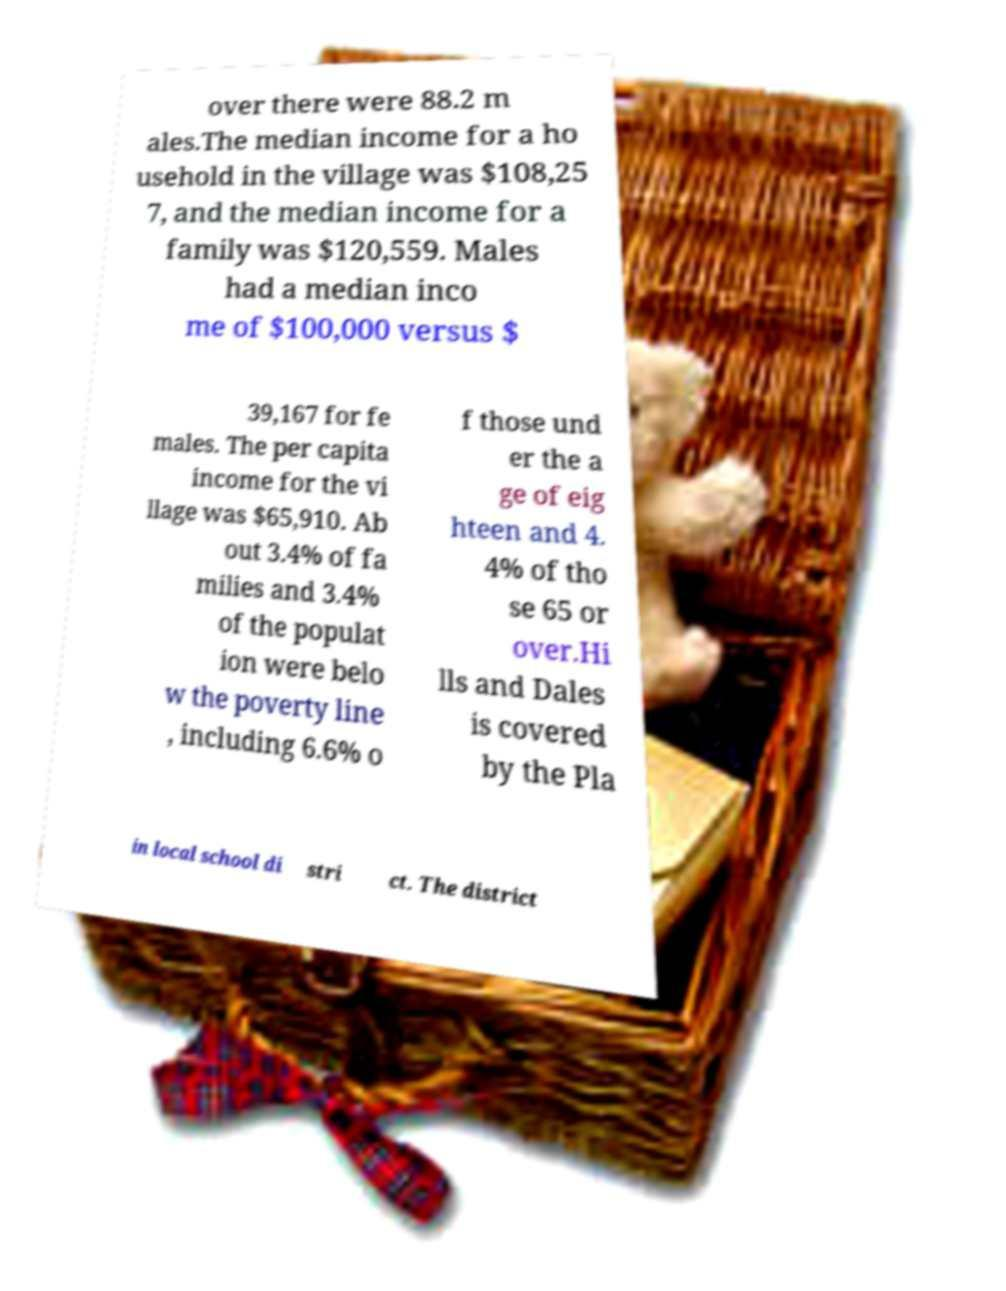Please identify and transcribe the text found in this image. over there were 88.2 m ales.The median income for a ho usehold in the village was $108,25 7, and the median income for a family was $120,559. Males had a median inco me of $100,000 versus $ 39,167 for fe males. The per capita income for the vi llage was $65,910. Ab out 3.4% of fa milies and 3.4% of the populat ion were belo w the poverty line , including 6.6% o f those und er the a ge of eig hteen and 4. 4% of tho se 65 or over.Hi lls and Dales is covered by the Pla in local school di stri ct. The district 